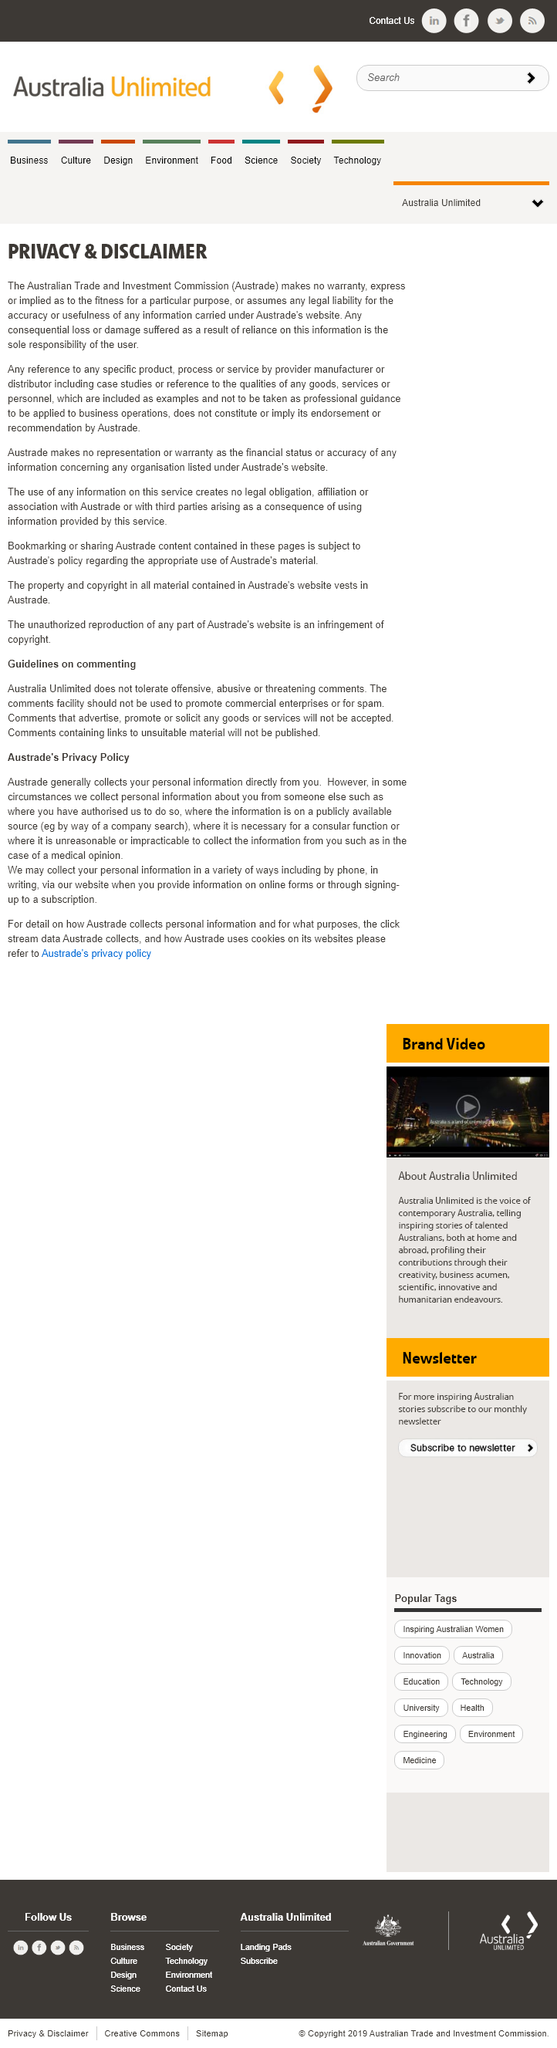Draw attention to some important aspects in this diagram. The privacy disclaimer states that a reference made by the Australian Trade and Investment Commission does not imply or constitute its endorsement or recommendation by Austrade. Austrate refers to the Australian Trade and Investment Commission, which is responsible for promoting and facilitating trade and investment between Australia and other countries. It is the user's responsibility to assume any loss or damage that may result from using Austrade's services. 